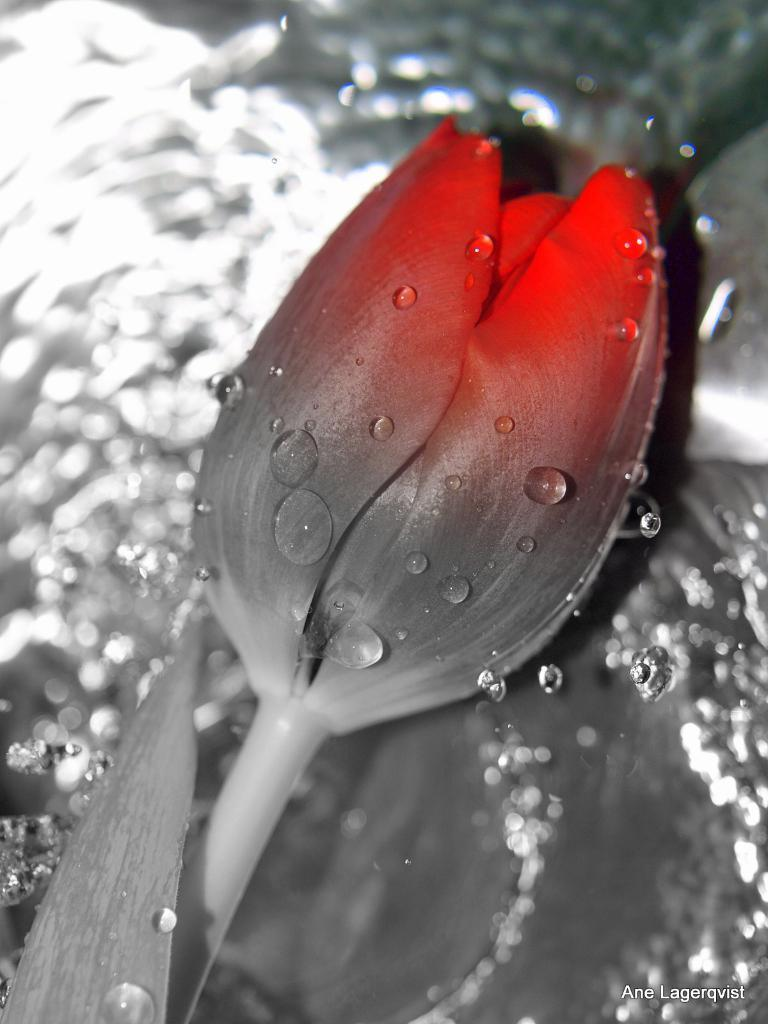What is the main subject of the picture? The main subject of the picture is a flower. Can you describe the appearance of the flower? The flower has water droplets on it. How many bulbs are connected to the flower in the image? There are no bulbs connected to the flower in the image. What type of ground is visible beneath the flower in the image? The image does not show the ground beneath the flower, so it cannot be determined from the image. 